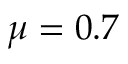Convert formula to latex. <formula><loc_0><loc_0><loc_500><loc_500>\mu = 0 . 7</formula> 